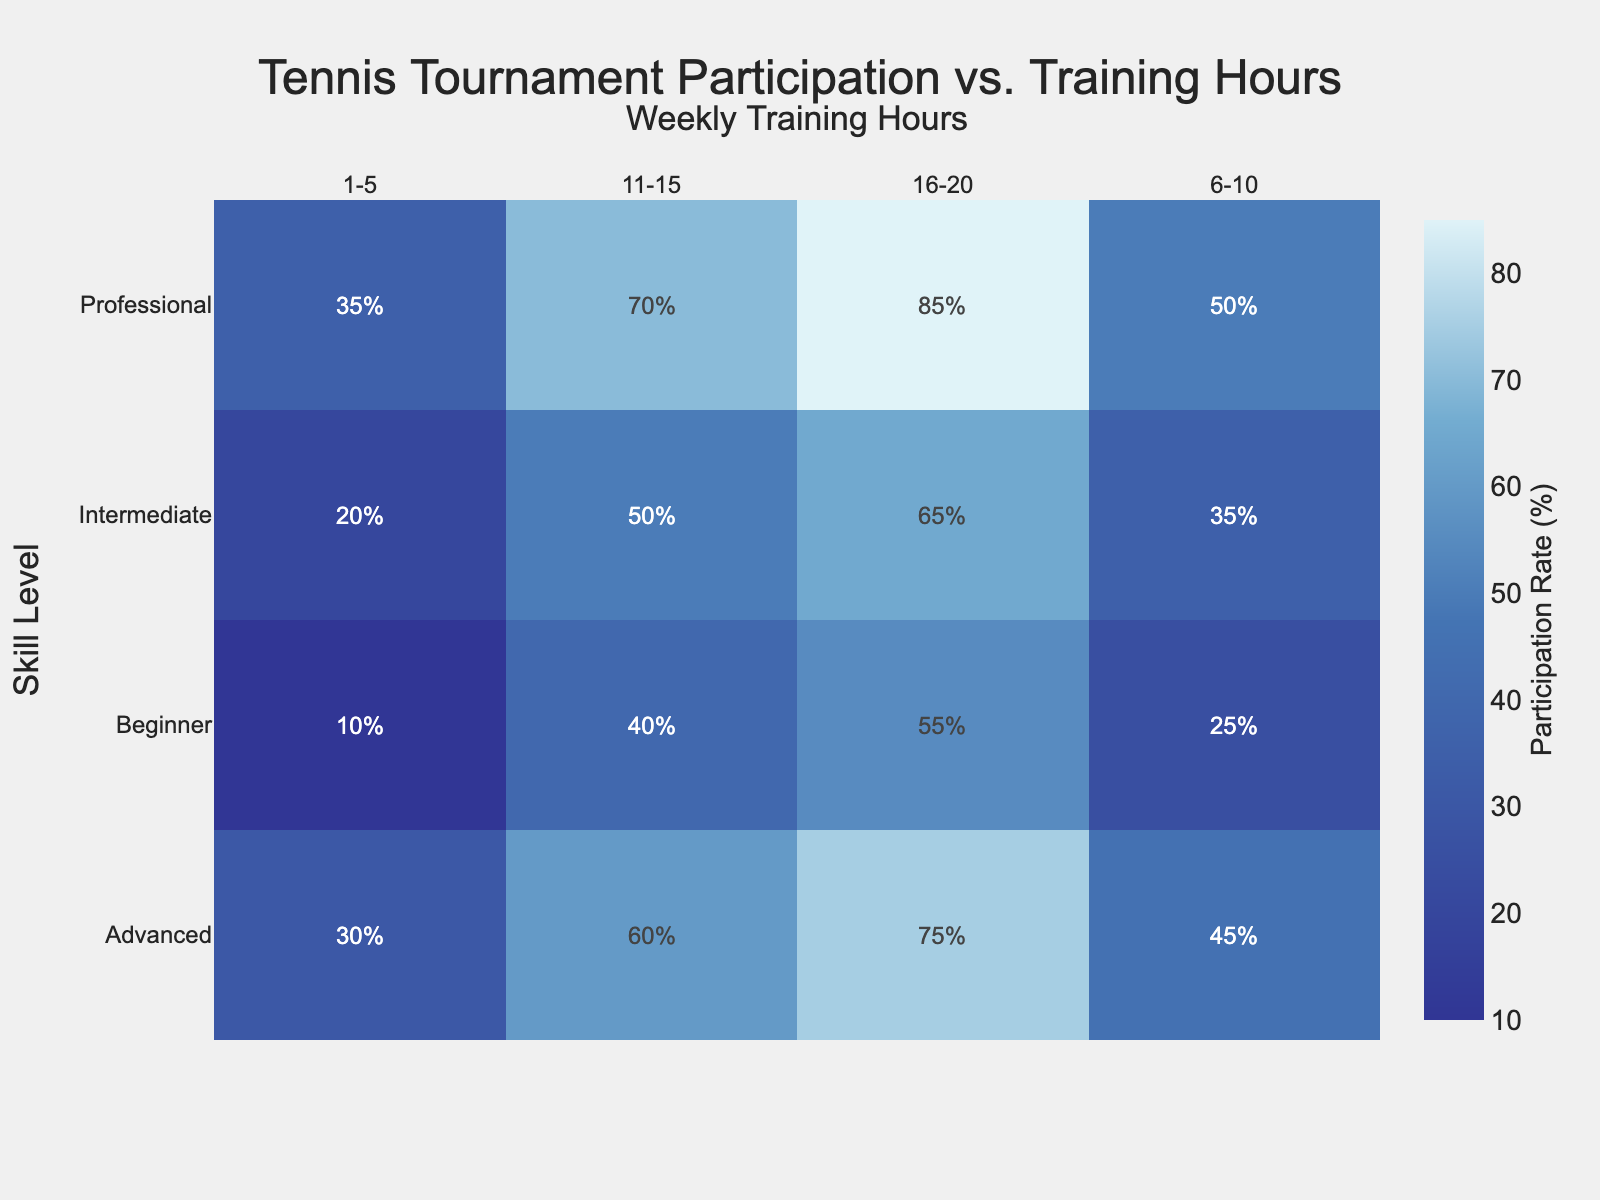Which skill level has the highest participation rate for 11-15 weekly training hours? Look across the row for 11-15 training hours and identify the highest rate. Professional skill level holds the highest participation rate at 70%.
Answer: Professional At 6-10 weekly training hours, which skill level shows the lowest participation rate? Look down the column for 6-10 training hours and find the lowest value. Beginner skill level has the lowest participation rate of 25%.
Answer: Beginner What is the average participation rate for Advanced players across all training hours? Add the participation rates for Advanced players and divide by the number of data points. (30+45+60+75) / 4 = 52.5.
Answer: 52.5 How much does the participation rate increase for Intermediate players from 1-5 hours to 16-20 hours of training? Subtract the value at 1-5 hours from the value at 16-20 hours for Intermediate players. 65 - 20 = 45.
Answer: 45 Compare the participation rates between Beginner and Professional players at 1-5 hours of training. Look at the rates for both Beginner and Professional at 1-5 training hours. Professional players have a rate of 35%, while Beginner players have a rate of 10%. Professional rate is higher.
Answer: Professional Which training hour range shows the greatest increase in participation rate for all skill levels? Calculate the differences between each step within each skill level and find the training hour range with the biggest increase in any skill level step. 
Beginner: 15, 15, 15
Intermediate: 15, 15, 15
Advanced: 15, 15, 15
Professional: 15, 20, 15 — 11-15 to 16-20 hours has the greatest increase of 20.
Answer: 11-15 to 16-20 Is there any skill level and training hour combination where the participation rate is exactly 50%? Check each cell for the exact 50% mark. 6-10 hours for Professional, and 16-20 hours for Intermediate show 50%.
Answer: Yes Which data ranges (skill level and training hours) reach a participation rate of over 70%? Identify the cells where the rates exceed 70%. Professional at 11-15 and 16-20 hours both exceed 70%, and Advanced at 16-20 hours does as well.
Answer: Professional (11-15, 16-20), Advanced (16-20) Do players at any skill level reach a 100% participation rate at any training hour? Look at all cells to check for a 100% rate. No cells contain a 100% rate.
Answer: No What is the participation rate difference between Advanced players at 16-20 training hours and Intermediate players at 11-15 hours? Subtract the participation rate for Intermediate at 11-15 hours from Advanced at 16-20 hours. 75 - 50 = 25.
Answer: 25 